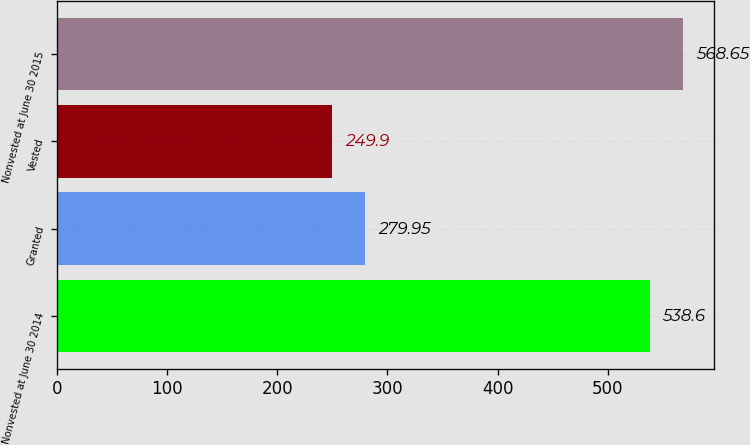Convert chart to OTSL. <chart><loc_0><loc_0><loc_500><loc_500><bar_chart><fcel>Nonvested at June 30 2014<fcel>Granted<fcel>Vested<fcel>Nonvested at June 30 2015<nl><fcel>538.6<fcel>279.95<fcel>249.9<fcel>568.65<nl></chart> 